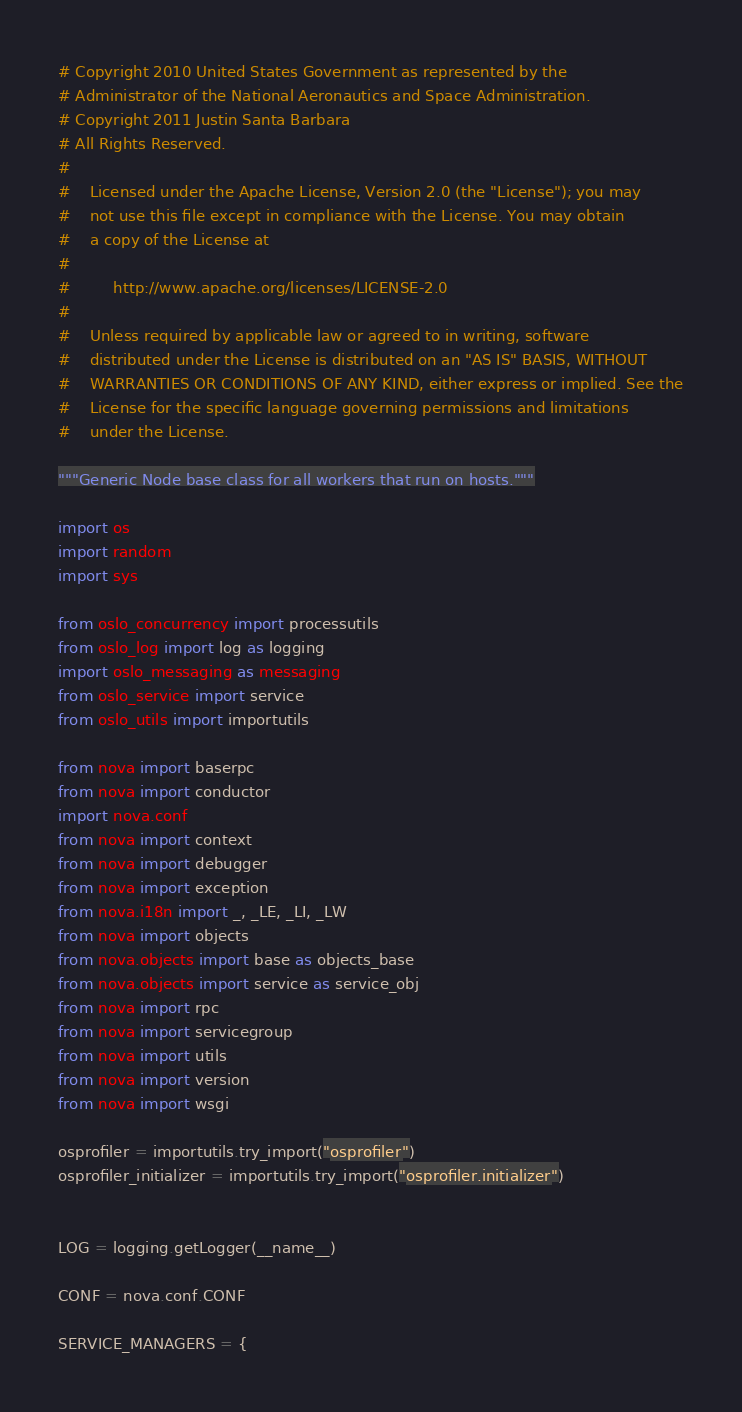<code> <loc_0><loc_0><loc_500><loc_500><_Python_># Copyright 2010 United States Government as represented by the
# Administrator of the National Aeronautics and Space Administration.
# Copyright 2011 Justin Santa Barbara
# All Rights Reserved.
#
#    Licensed under the Apache License, Version 2.0 (the "License"); you may
#    not use this file except in compliance with the License. You may obtain
#    a copy of the License at
#
#         http://www.apache.org/licenses/LICENSE-2.0
#
#    Unless required by applicable law or agreed to in writing, software
#    distributed under the License is distributed on an "AS IS" BASIS, WITHOUT
#    WARRANTIES OR CONDITIONS OF ANY KIND, either express or implied. See the
#    License for the specific language governing permissions and limitations
#    under the License.

"""Generic Node base class for all workers that run on hosts."""

import os
import random
import sys

from oslo_concurrency import processutils
from oslo_log import log as logging
import oslo_messaging as messaging
from oslo_service import service
from oslo_utils import importutils

from nova import baserpc
from nova import conductor
import nova.conf
from nova import context
from nova import debugger
from nova import exception
from nova.i18n import _, _LE, _LI, _LW
from nova import objects
from nova.objects import base as objects_base
from nova.objects import service as service_obj
from nova import rpc
from nova import servicegroup
from nova import utils
from nova import version
from nova import wsgi

osprofiler = importutils.try_import("osprofiler")
osprofiler_initializer = importutils.try_import("osprofiler.initializer")


LOG = logging.getLogger(__name__)

CONF = nova.conf.CONF

SERVICE_MANAGERS = {</code> 